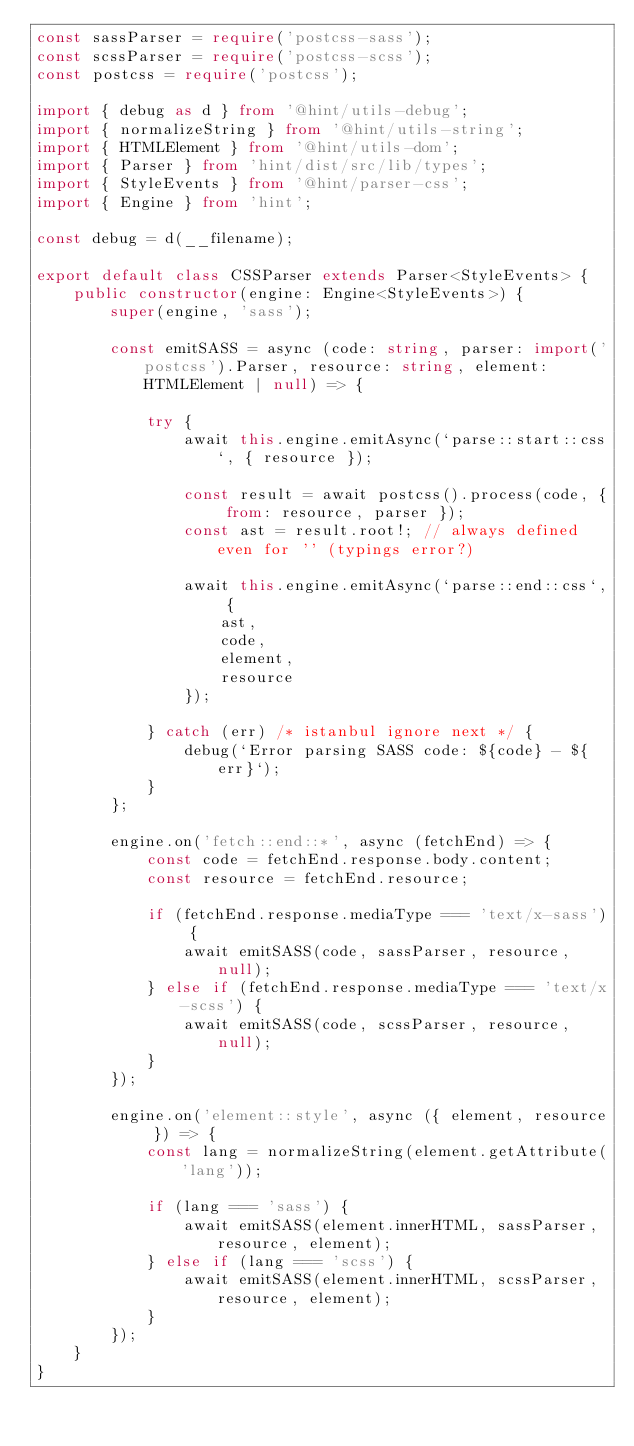Convert code to text. <code><loc_0><loc_0><loc_500><loc_500><_TypeScript_>const sassParser = require('postcss-sass');
const scssParser = require('postcss-scss');
const postcss = require('postcss');

import { debug as d } from '@hint/utils-debug';
import { normalizeString } from '@hint/utils-string';
import { HTMLElement } from '@hint/utils-dom';
import { Parser } from 'hint/dist/src/lib/types';
import { StyleEvents } from '@hint/parser-css';
import { Engine } from 'hint';

const debug = d(__filename);

export default class CSSParser extends Parser<StyleEvents> {
    public constructor(engine: Engine<StyleEvents>) {
        super(engine, 'sass');

        const emitSASS = async (code: string, parser: import('postcss').Parser, resource: string, element: HTMLElement | null) => {

            try {
                await this.engine.emitAsync(`parse::start::css`, { resource });

                const result = await postcss().process(code, { from: resource, parser });
                const ast = result.root!; // always defined even for '' (typings error?)

                await this.engine.emitAsync(`parse::end::css`, {
                    ast,
                    code,
                    element,
                    resource
                });

            } catch (err) /* istanbul ignore next */ {
                debug(`Error parsing SASS code: ${code} - ${err}`);
            }
        };

        engine.on('fetch::end::*', async (fetchEnd) => {
            const code = fetchEnd.response.body.content;
            const resource = fetchEnd.resource;

            if (fetchEnd.response.mediaType === 'text/x-sass') {
                await emitSASS(code, sassParser, resource, null);
            } else if (fetchEnd.response.mediaType === 'text/x-scss') {
                await emitSASS(code, scssParser, resource, null);
            }
        });

        engine.on('element::style', async ({ element, resource }) => {
            const lang = normalizeString(element.getAttribute('lang'));

            if (lang === 'sass') {
                await emitSASS(element.innerHTML, sassParser, resource, element);
            } else if (lang === 'scss') {
                await emitSASS(element.innerHTML, scssParser, resource, element);
            }
        });
    }
}
</code> 